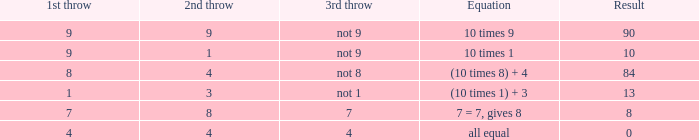If the formula is (10 multiplied by 1) + 3, what is the 2nd toss? 3.0. 